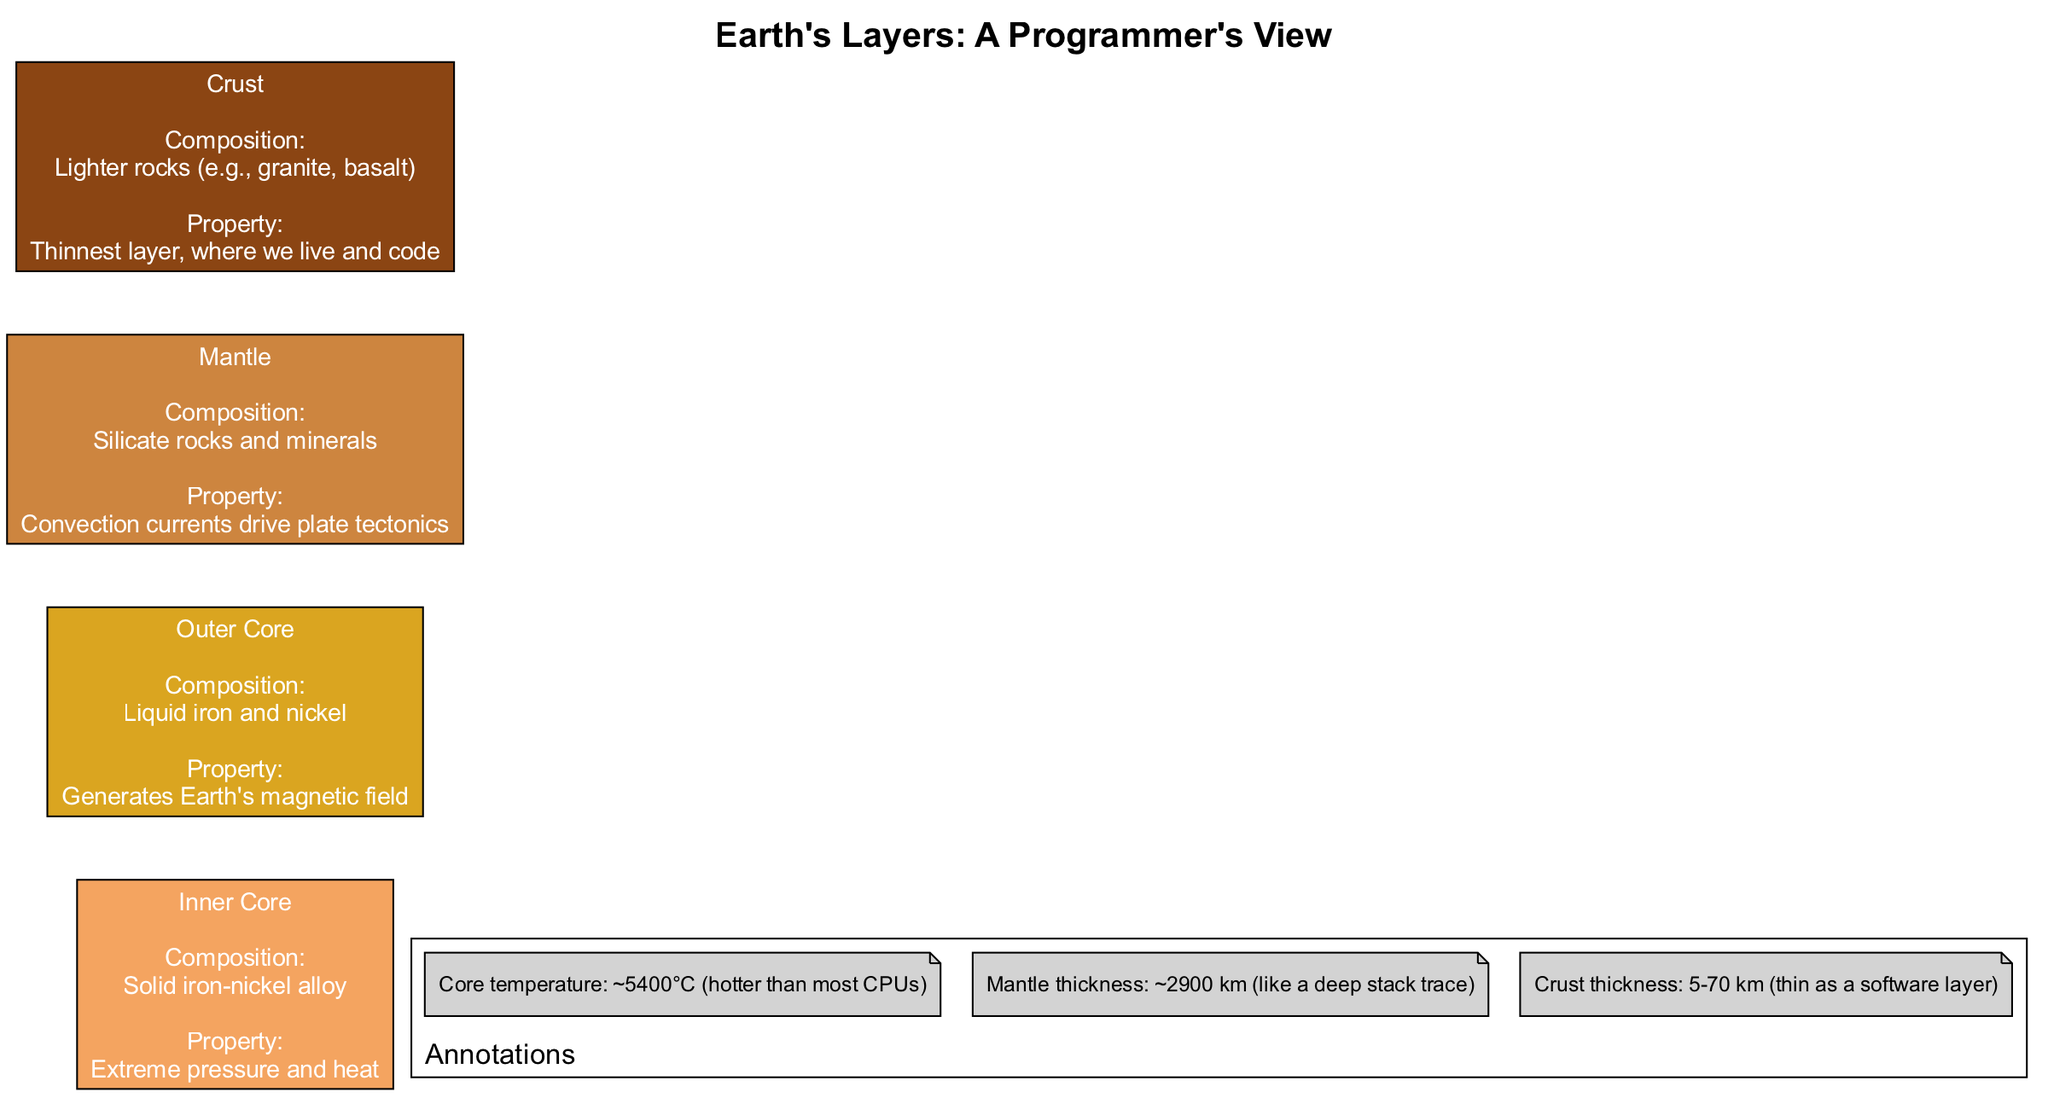What is the composition of the Outer Core? The diagram lists the composition of the Outer Core as "Liquid iron and nickel" in the node representing this layer.
Answer: Liquid iron and nickel What property is associated with the Inner Core? The diagram indicates that the Inner Core has the property of "Extreme pressure and heat," as labeled in the node for this layer.
Answer: Extreme pressure and heat How many layers are represented in the diagram? There are four layers presented in the diagram: Inner Core, Outer Core, Mantle, and Crust. Counting these layers gives a total of four.
Answer: 4 Which layer is the thinnest? The diagram shows that the Crust is labeled as "Thinnest layer, where we live and code," making it the thinnest layer in the Earth's structure.
Answer: Crust What generates Earth’s magnetic field? According to the diagram, the property of the Outer Core is indicated to "Generate Earth's magnetic field," which provides the answer to the question.
Answer: Outer Core What is the thickness of the Mantle? The annotations in the diagram state that the Mantle thickness is about "2900 km." This number is directly stated as part of the information provided about the Mantle.
Answer: 2900 km What is the core temperature mentioned in the annotations? The diagram specifies an annotation stating the core temperature is approximately "5400°C." Referring to the annotations gives the answer to this question.
Answer: 5400°C What type of rocks is the Crust composed of? In the Crust's node, the composition is noted as "Lighter rocks (e.g., granite, basalt)," which directly answers the question regarding the composition of the Crust.
Answer: Lighter rocks (e.g., granite, basalt) What do convection currents in the Mantle drive? The diagram asserts that convection currents in the Mantle are responsible for "driving plate tectonics," thus answering the question regarding what these currents influence.
Answer: Plate tectonics 